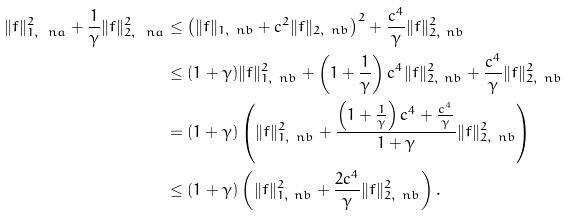<formula> <loc_0><loc_0><loc_500><loc_500>\| f \| _ { 1 , \ n a } ^ { 2 } + \frac { 1 } { \gamma } \| f \| _ { 2 , \ n a } ^ { 2 } & \leq \left ( \| f \| _ { 1 , \ n b } + c ^ { 2 } \| f \| _ { 2 , \ n b } \right ) ^ { 2 } + \frac { c ^ { 4 } } { \gamma } \| f \| _ { 2 , \ n b } ^ { 2 } \\ & \leq ( 1 + \gamma ) \| f \| _ { 1 , \ n b } ^ { 2 } + \left ( 1 + \frac { 1 } { \gamma } \right ) c ^ { 4 } \| f \| _ { 2 , \ n b } ^ { 2 } + \frac { c ^ { 4 } } { \gamma } \| f \| _ { 2 , \ n b } ^ { 2 } \\ & = ( 1 + \gamma ) \left ( \| f \| _ { 1 , \ n b } ^ { 2 } + \frac { \left ( 1 + \frac { 1 } { \gamma } \right ) c ^ { 4 } + \frac { c ^ { 4 } } { \gamma } } { 1 + \gamma } \| f \| _ { 2 , \ n b } ^ { 2 } \right ) \\ & \leq ( 1 + \gamma ) \left ( \| f \| _ { 1 , \ n b } ^ { 2 } + \frac { 2 c ^ { 4 } } { \gamma } \| f \| _ { 2 , \ n b } ^ { 2 } \right ) .</formula> 